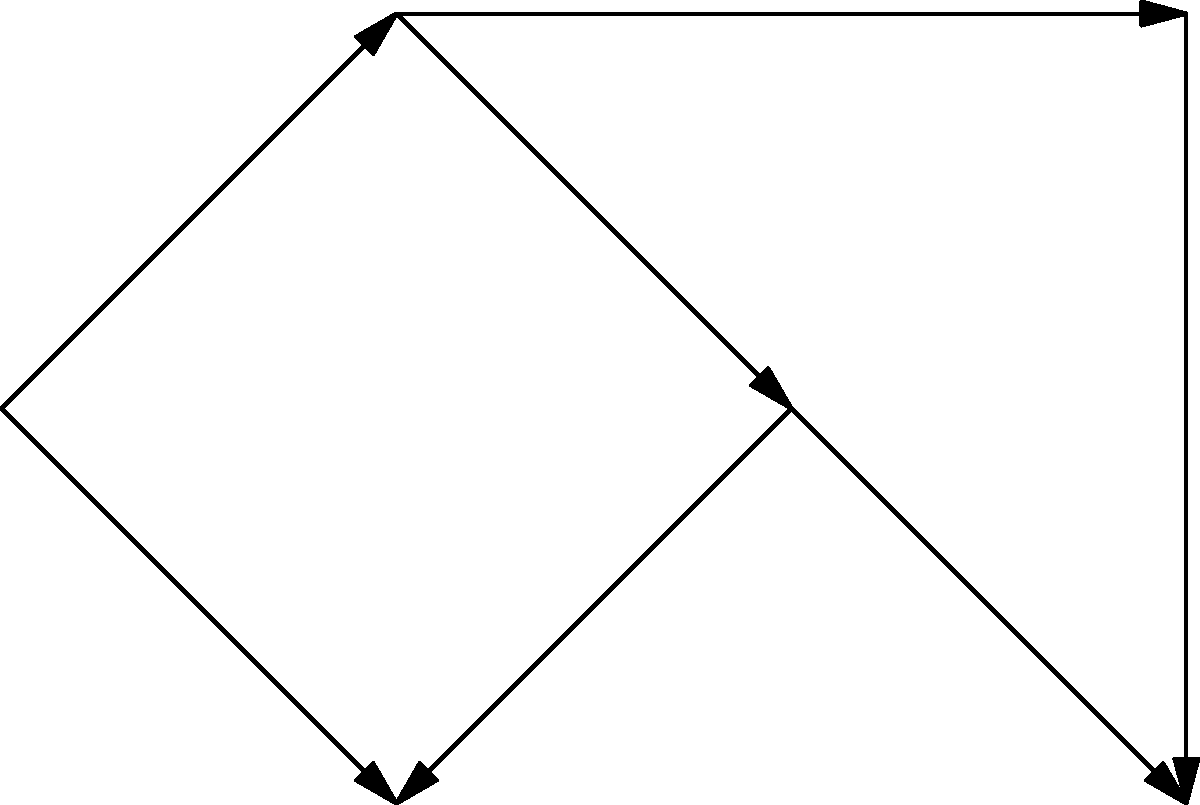In the network graph above, which represents communication patterns in a group, what type of network structure is demonstrated, and how might this impact information flow and group dynamics? To analyze this network structure and its impact on group dynamics, let's follow these steps:

1. Identify the structure:
   - The graph shows 6 nodes (A, B, C, D, E, F) connected by directed edges.
   - There is no central node connecting to all others.
   - The structure resembles a chain or line with some additional connections.

2. Classify the network type:
   - This is a decentralized network structure.
   - It's not fully connected (not all nodes are directly linked to each other).
   - It's not a star network (no central hub).
   - It shows characteristics of a chain network with some additional links.

3. Analyze information flow:
   - Information can flow from A to F through multiple paths.
   - The longest path is A → B → C → E → F.
   - Shorter paths exist, e.g., A → D → C → E → F.
   - Bidirectional communication is not possible for all connections.

4. Impact on group dynamics:
   - Moderate speed of information dissemination due to multiple paths.
   - Risk of information distortion as it passes through intermediaries.
   - Potential for subgroups to form (e.g., ABC and DEF).
   - No single point of failure or control, enhancing resilience.
   - Moderate flexibility in communication patterns.

5. Psychological implications:
   - May foster collaboration between adjacent nodes.
   - Could lead to varying levels of influence among group members.
   - Potential for information gatekeeping at key nodes (e.g., C).
   - May require more effort to maintain group cohesion compared to centralized networks.

This decentralized structure balances efficiency and resilience, potentially promoting more democratic group processes while maintaining some structure in communication flow.
Answer: Decentralized network; balances efficiency and resilience, promotes democratic processes with structured communication flow. 